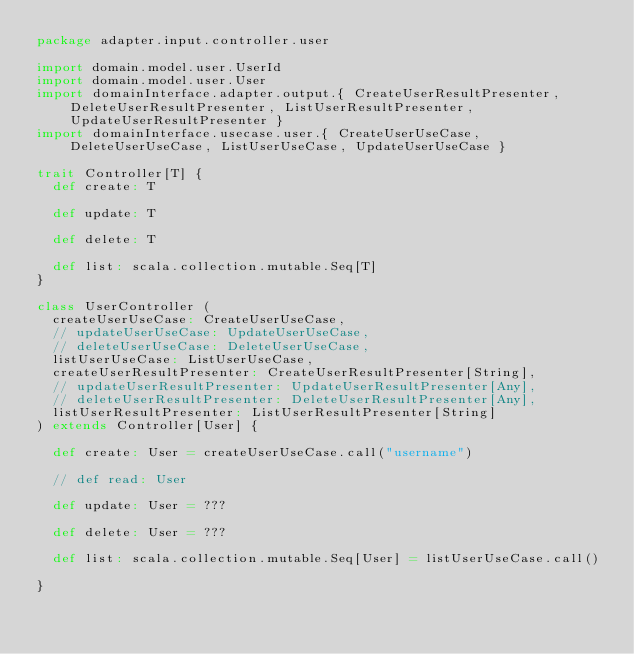<code> <loc_0><loc_0><loc_500><loc_500><_Scala_>package adapter.input.controller.user

import domain.model.user.UserId
import domain.model.user.User
import domainInterface.adapter.output.{ CreateUserResultPresenter, DeleteUserResultPresenter, ListUserResultPresenter, UpdateUserResultPresenter }
import domainInterface.usecase.user.{ CreateUserUseCase, DeleteUserUseCase, ListUserUseCase, UpdateUserUseCase }

trait Controller[T] {
  def create: T

  def update: T

  def delete: T

  def list: scala.collection.mutable.Seq[T]
}

class UserController (
  createUserUseCase: CreateUserUseCase,
  // updateUserUseCase: UpdateUserUseCase,
  // deleteUserUseCase: DeleteUserUseCase,
  listUserUseCase: ListUserUseCase,
  createUserResultPresenter: CreateUserResultPresenter[String],
  // updateUserResultPresenter: UpdateUserResultPresenter[Any],
  // deleteUserResultPresenter: DeleteUserResultPresenter[Any],
  listUserResultPresenter: ListUserResultPresenter[String]
) extends Controller[User] {

  def create: User = createUserUseCase.call("username")

  // def read: User

  def update: User = ???

  def delete: User = ???

  def list: scala.collection.mutable.Seq[User] = listUserUseCase.call()

}
</code> 